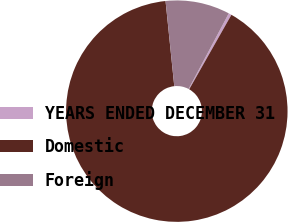Convert chart. <chart><loc_0><loc_0><loc_500><loc_500><pie_chart><fcel>YEARS ENDED DECEMBER 31<fcel>Domestic<fcel>Foreign<nl><fcel>0.43%<fcel>90.17%<fcel>9.4%<nl></chart> 